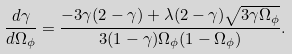<formula> <loc_0><loc_0><loc_500><loc_500>\frac { d \gamma } { d \Omega _ { \phi } } = \frac { - 3 \gamma ( 2 - \gamma ) + \lambda ( 2 - \gamma ) \sqrt { 3 \gamma \Omega _ { \phi } } } { 3 ( 1 - \gamma ) \Omega _ { \phi } ( 1 - \Omega _ { \phi } ) } .</formula> 